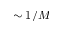Convert formula to latex. <formula><loc_0><loc_0><loc_500><loc_500>\sim 1 / M</formula> 